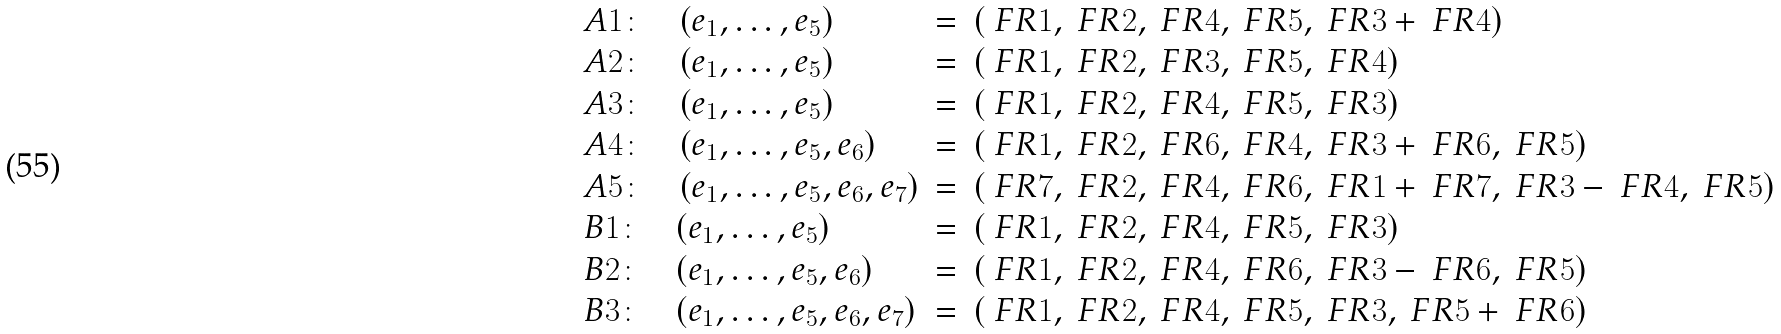<formula> <loc_0><loc_0><loc_500><loc_500>\begin{array} { l c l } A 1 \colon \quad ( e _ { 1 } , \dots , e _ { 5 } ) & = & ( \ F R { 1 } , \ F R { 2 } , \ F R { 4 } , \ F R { 5 } , \ F R { 3 } + \ F R { 4 } ) \\ A 2 \colon \quad ( e _ { 1 } , \dots , e _ { 5 } ) & = & ( \ F R { 1 } , \ F R { 2 } , \ F R { 3 } , \ F R { 5 } , \ F R { 4 } ) \\ A 3 \colon \quad ( e _ { 1 } , \dots , e _ { 5 } ) & = & ( \ F R { 1 } , \ F R { 2 } , \ F R { 4 } , \ F R { 5 } , \ F R { 3 } ) \\ A 4 \colon \quad ( e _ { 1 } , \dots , e _ { 5 } , e _ { 6 } ) & = & ( \ F R { 1 } , \ F R { 2 } , \ F R { 6 } , \ F R { 4 } , \ F R { 3 } + \ F R { 6 } , \ F R { 5 } ) \\ A 5 \colon \quad ( e _ { 1 } , \dots , e _ { 5 } , e _ { 6 } , e _ { 7 } ) & = & ( \ F R { 7 } , \ F R { 2 } , \ F R { 4 } , \ F R { 6 } , \ F R { 1 } + \ F R { 7 } , \ F R { 3 } - \ F R { 4 } , \ F R { 5 } ) \\ B 1 \colon \quad ( e _ { 1 } , \dots , e _ { 5 } ) & = & ( \ F R { 1 } , \ F R { 2 } , \ F R { 4 } , \ F R { 5 } , \ F R { 3 } ) \\ B 2 \colon \quad ( e _ { 1 } , \dots , e _ { 5 } , e _ { 6 } ) & = & ( \ F R { 1 } , \ F R { 2 } , \ F R { 4 } , \ F R { 6 } , \ F R { 3 } - \ F R { 6 } , \ F R { 5 } ) \\ B 3 \colon \quad ( e _ { 1 } , \dots , e _ { 5 } , e _ { 6 } , e _ { 7 } ) & = & ( \ F R { 1 } , \ F R { 2 } , \ F R { 4 } , \ F R { 5 } , \ F R { 3 } , \ F R { 5 } + \ F R { 6 } ) \end{array}</formula> 